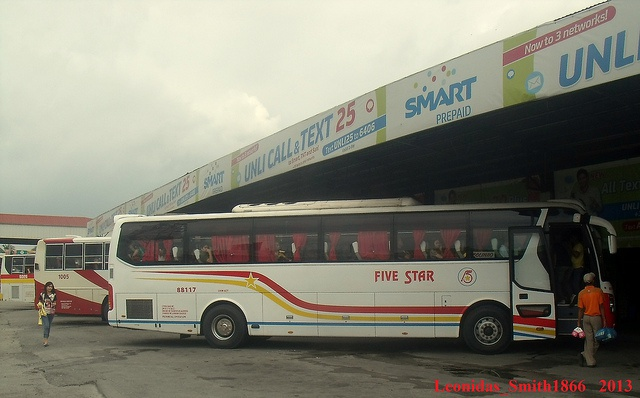Describe the objects in this image and their specific colors. I can see bus in beige, black, darkgray, gray, and maroon tones, bus in beige, darkgray, maroon, black, and gray tones, people in beige, black, and maroon tones, bus in beige, darkgray, gray, black, and tan tones, and people in black and beige tones in this image. 